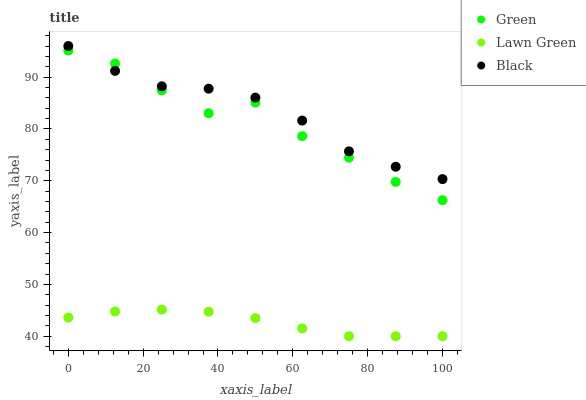Does Lawn Green have the minimum area under the curve?
Answer yes or no. Yes. Does Black have the maximum area under the curve?
Answer yes or no. Yes. Does Green have the minimum area under the curve?
Answer yes or no. No. Does Green have the maximum area under the curve?
Answer yes or no. No. Is Lawn Green the smoothest?
Answer yes or no. Yes. Is Green the roughest?
Answer yes or no. Yes. Is Black the smoothest?
Answer yes or no. No. Is Black the roughest?
Answer yes or no. No. Does Lawn Green have the lowest value?
Answer yes or no. Yes. Does Green have the lowest value?
Answer yes or no. No. Does Black have the highest value?
Answer yes or no. Yes. Does Green have the highest value?
Answer yes or no. No. Is Lawn Green less than Black?
Answer yes or no. Yes. Is Green greater than Lawn Green?
Answer yes or no. Yes. Does Green intersect Black?
Answer yes or no. Yes. Is Green less than Black?
Answer yes or no. No. Is Green greater than Black?
Answer yes or no. No. Does Lawn Green intersect Black?
Answer yes or no. No. 